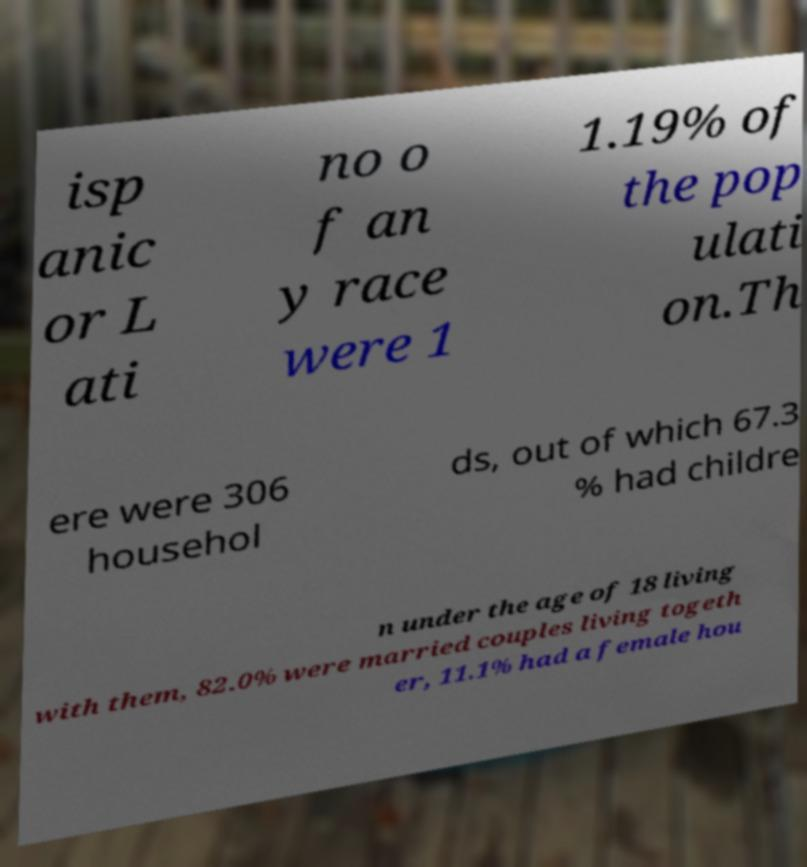What messages or text are displayed in this image? I need them in a readable, typed format. isp anic or L ati no o f an y race were 1 1.19% of the pop ulati on.Th ere were 306 househol ds, out of which 67.3 % had childre n under the age of 18 living with them, 82.0% were married couples living togeth er, 11.1% had a female hou 